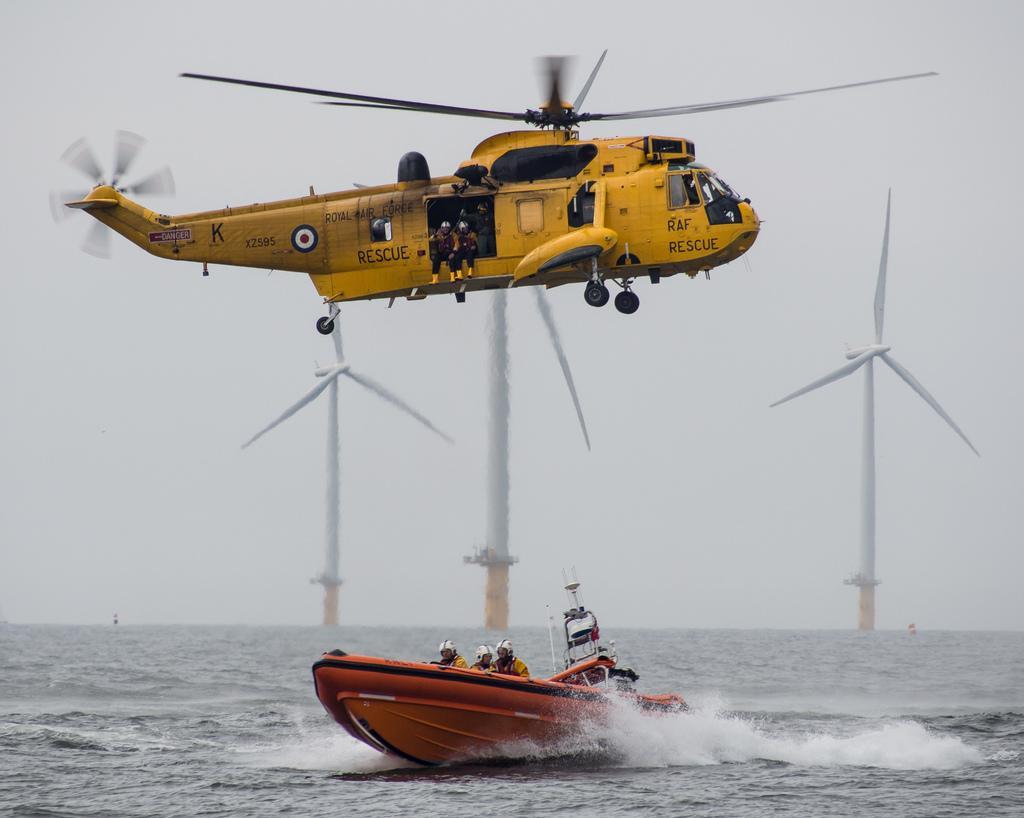In one or two sentences, can you explain what this image depicts? In this image I can see helicopter flying. There is a boat on the water. There are few people and there are windmills. In the background there is sky. 